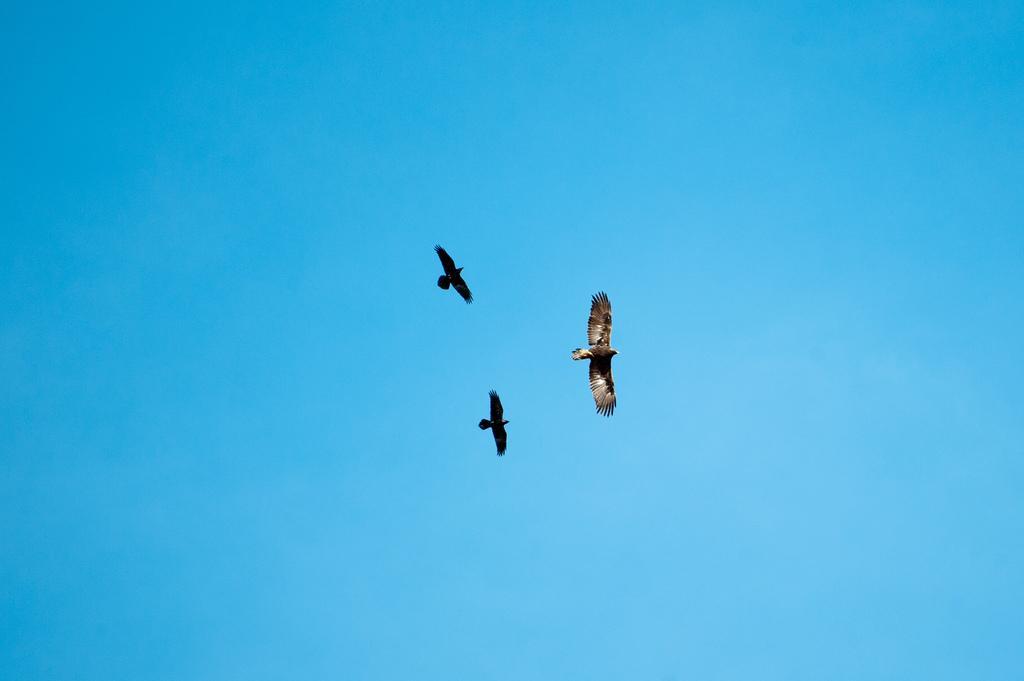Describe this image in one or two sentences. In this image there are three birds in the air. In the background of the image there is sky. 